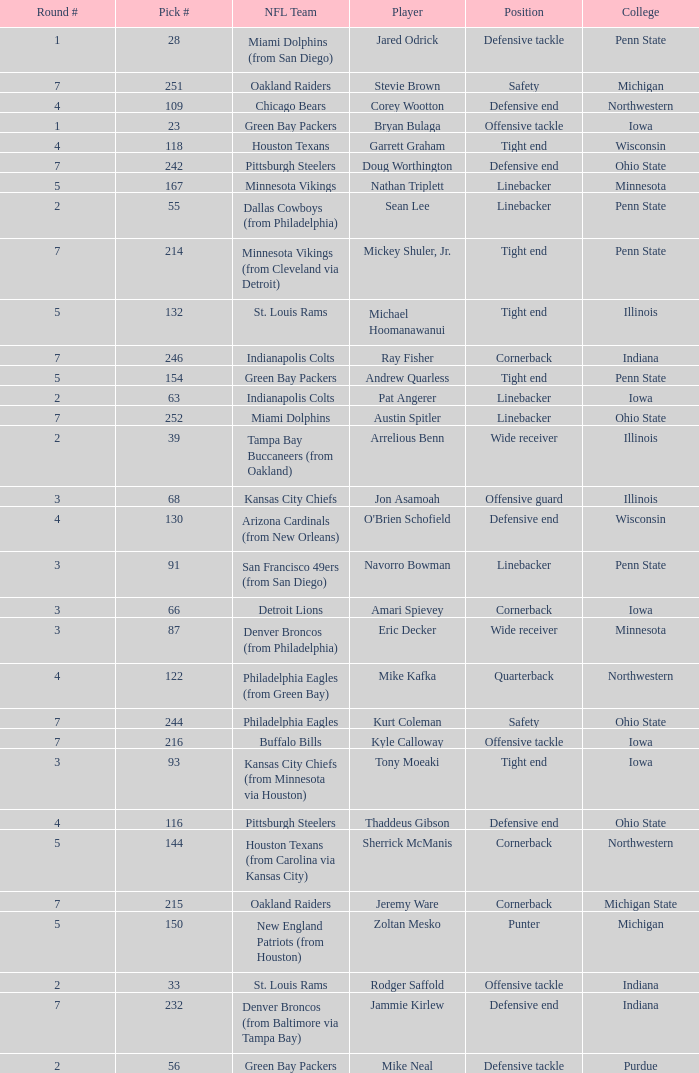What NFL team was the player with pick number 28 drafted to? Miami Dolphins (from San Diego). 